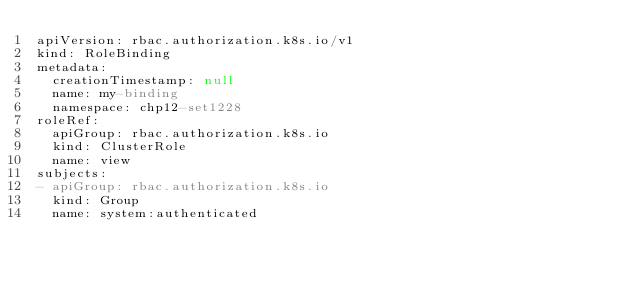<code> <loc_0><loc_0><loc_500><loc_500><_YAML_>apiVersion: rbac.authorization.k8s.io/v1
kind: RoleBinding
metadata:
  creationTimestamp: null
  name: my-binding
  namespace: chp12-set1228
roleRef:
  apiGroup: rbac.authorization.k8s.io
  kind: ClusterRole
  name: view
subjects:
- apiGroup: rbac.authorization.k8s.io
  kind: Group
  name: system:authenticated
</code> 